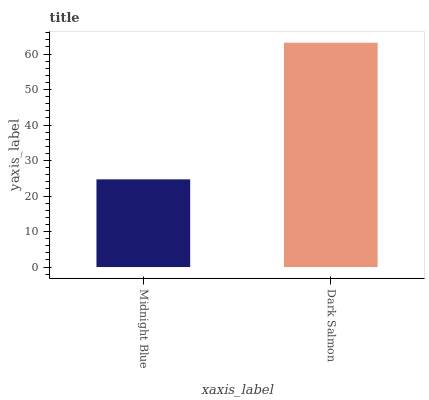Is Dark Salmon the minimum?
Answer yes or no. No. Is Dark Salmon greater than Midnight Blue?
Answer yes or no. Yes. Is Midnight Blue less than Dark Salmon?
Answer yes or no. Yes. Is Midnight Blue greater than Dark Salmon?
Answer yes or no. No. Is Dark Salmon less than Midnight Blue?
Answer yes or no. No. Is Dark Salmon the high median?
Answer yes or no. Yes. Is Midnight Blue the low median?
Answer yes or no. Yes. Is Midnight Blue the high median?
Answer yes or no. No. Is Dark Salmon the low median?
Answer yes or no. No. 